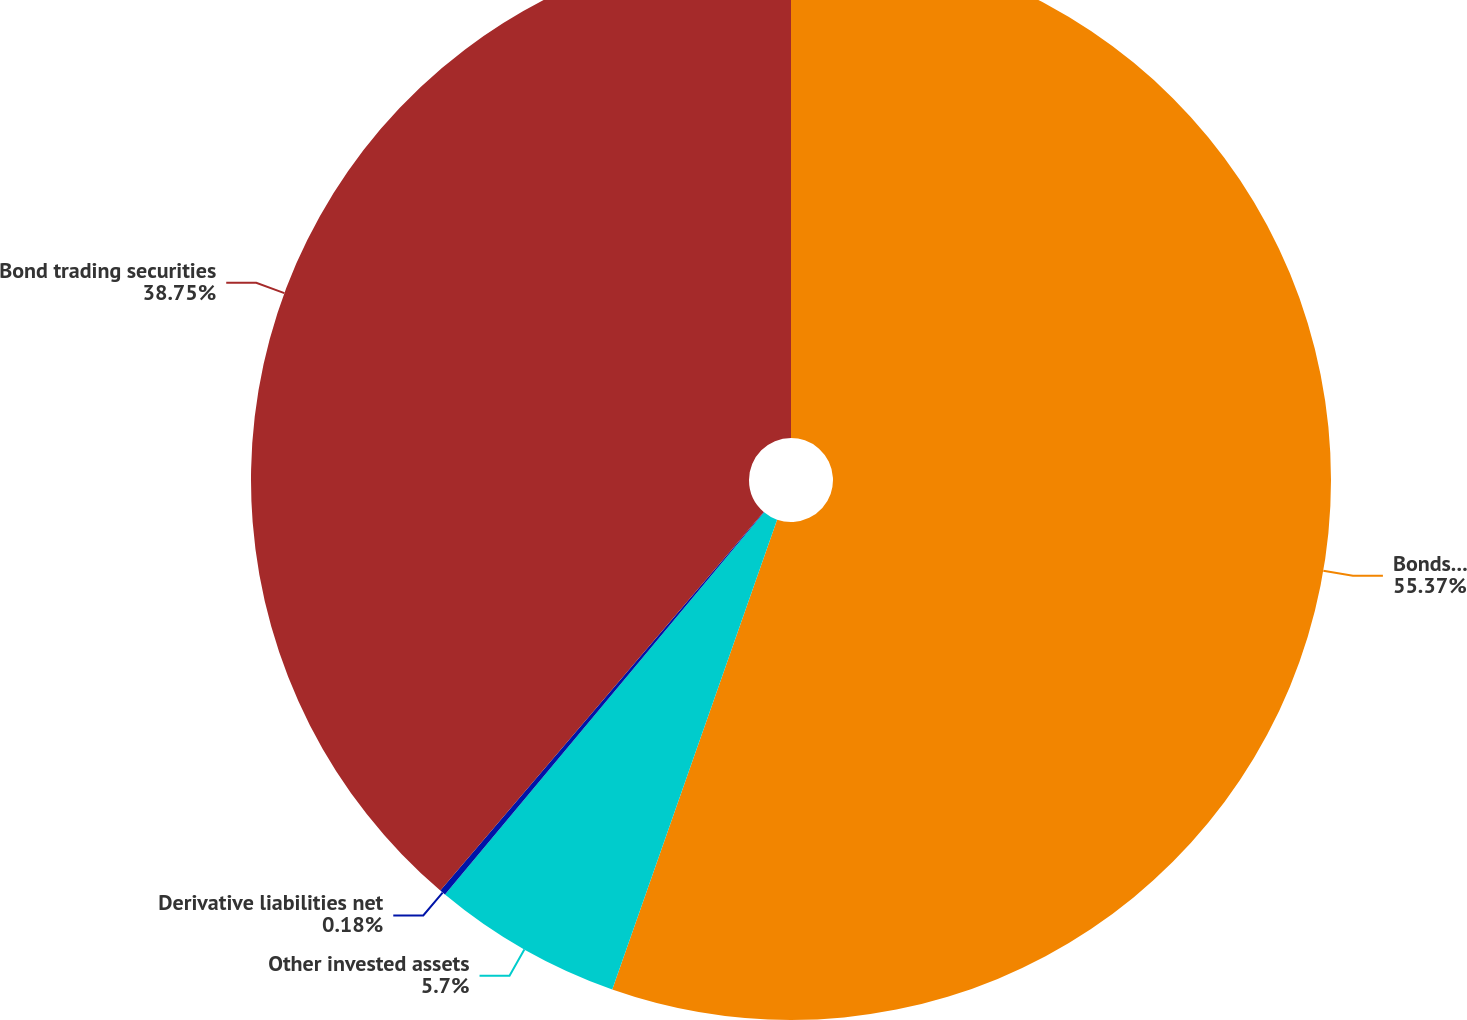Convert chart. <chart><loc_0><loc_0><loc_500><loc_500><pie_chart><fcel>Bonds available for sale<fcel>Other invested assets<fcel>Derivative liabilities net<fcel>Bond trading securities<nl><fcel>55.37%<fcel>5.7%<fcel>0.18%<fcel>38.75%<nl></chart> 